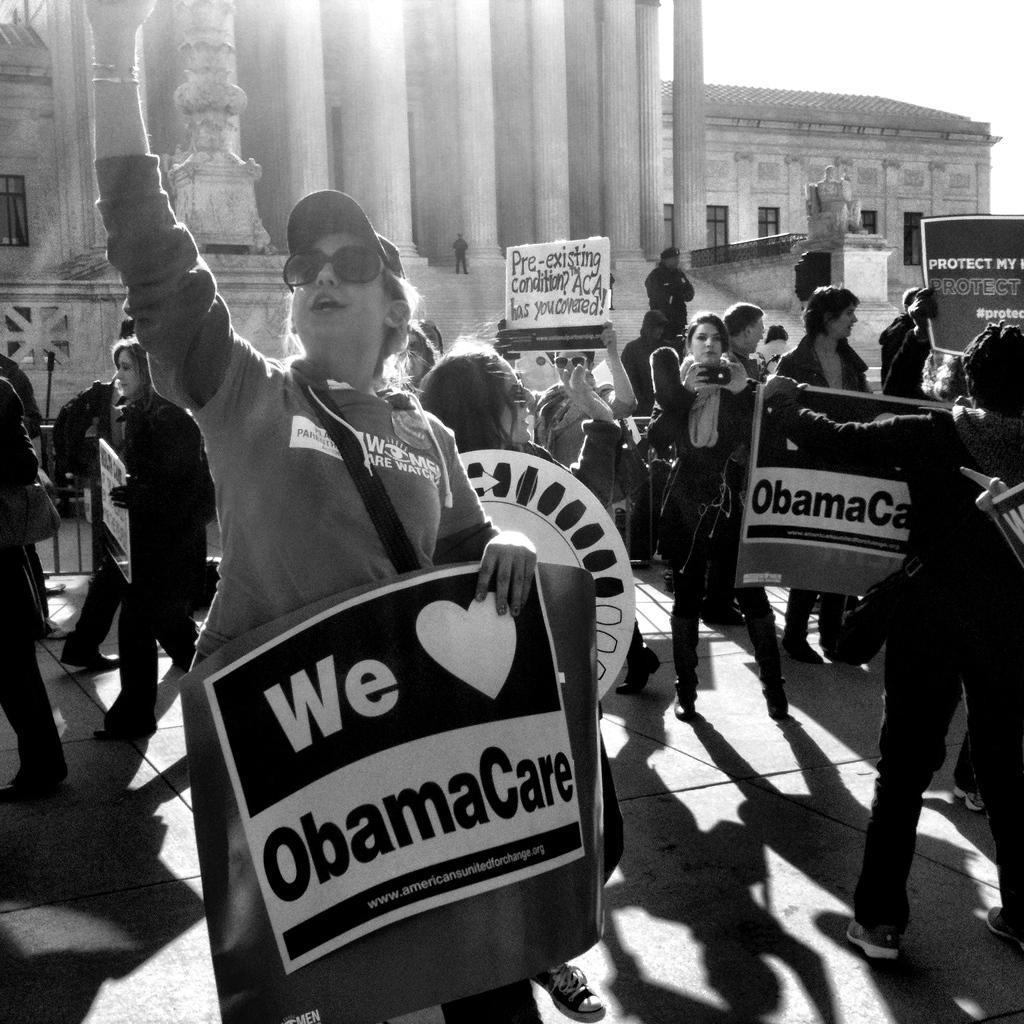Could you give a brief overview of what you see in this image? This is a black and white image. I can see a group of people standing and holding the boards. In the background, there are buildings with windows, pillars and a sculpture. 